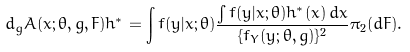<formula> <loc_0><loc_0><loc_500><loc_500>d _ { g } A ( x ; \theta , g , F ) h ^ { * } = \int f ( y | x ; \theta ) \frac { \int f ( y | x ; \theta ) h ^ { * } ( x ) \, d x } { \{ f _ { Y } ( y ; \theta , g ) \} ^ { 2 } } \pi _ { 2 } ( d F ) .</formula> 